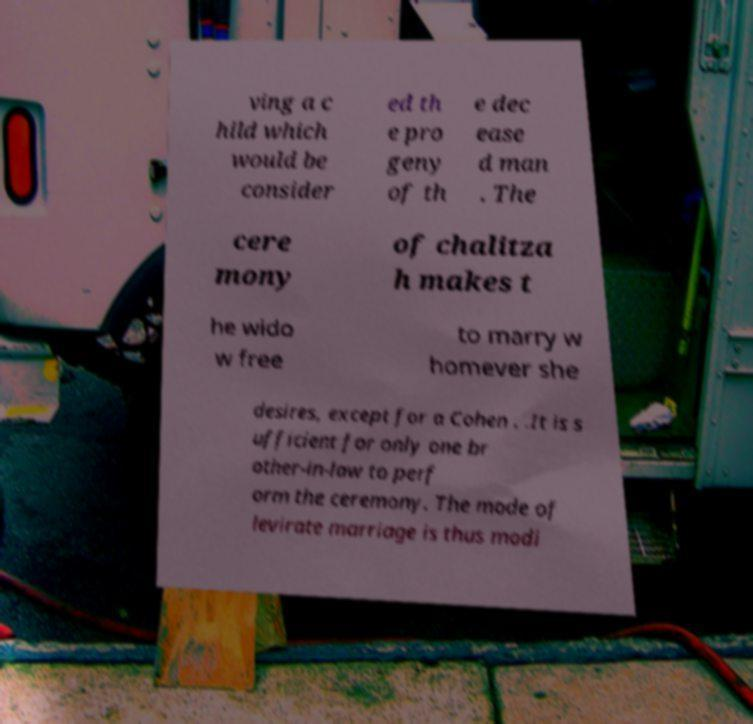Can you accurately transcribe the text from the provided image for me? ving a c hild which would be consider ed th e pro geny of th e dec ease d man . The cere mony of chalitza h makes t he wido w free to marry w homever she desires, except for a Cohen . .It is s ufficient for only one br other-in-law to perf orm the ceremony. The mode of levirate marriage is thus modi 